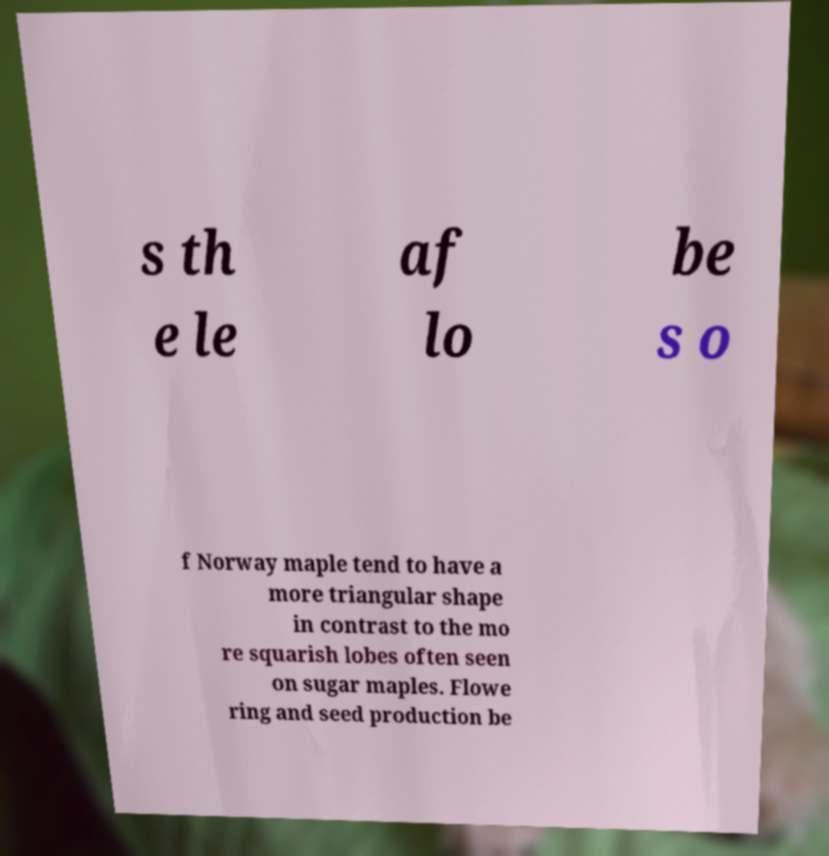There's text embedded in this image that I need extracted. Can you transcribe it verbatim? s th e le af lo be s o f Norway maple tend to have a more triangular shape in contrast to the mo re squarish lobes often seen on sugar maples. Flowe ring and seed production be 